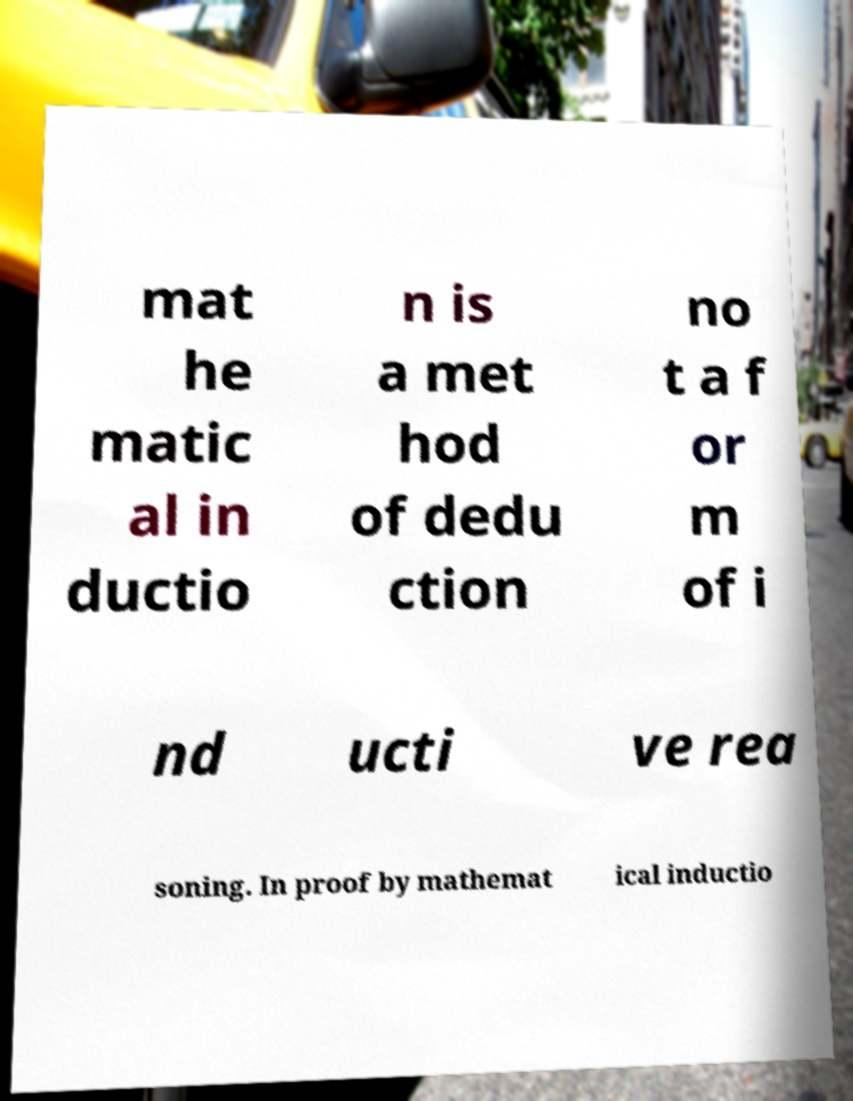Can you read and provide the text displayed in the image?This photo seems to have some interesting text. Can you extract and type it out for me? mat he matic al in ductio n is a met hod of dedu ction no t a f or m of i nd ucti ve rea soning. In proof by mathemat ical inductio 